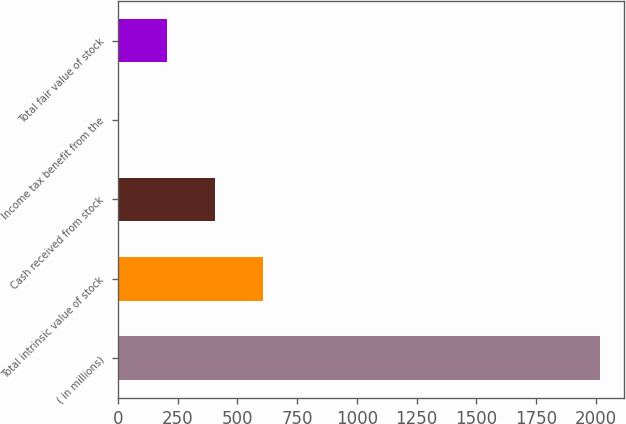Convert chart. <chart><loc_0><loc_0><loc_500><loc_500><bar_chart><fcel>( in millions)<fcel>Total intrinsic value of stock<fcel>Cash received from stock<fcel>Income tax benefit from the<fcel>Total fair value of stock<nl><fcel>2018<fcel>608.2<fcel>406.8<fcel>4<fcel>205.4<nl></chart> 